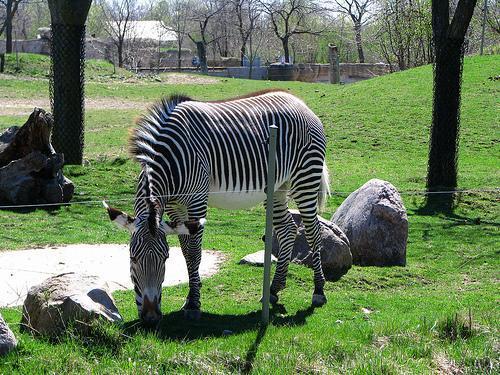How many zebras are there?
Give a very brief answer. 1. 